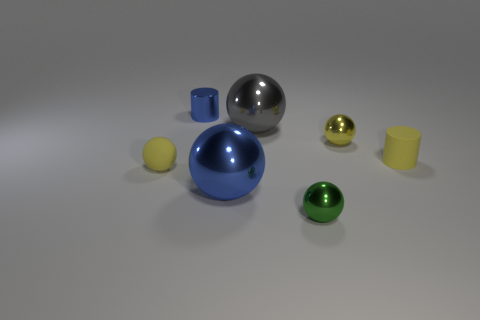Are there any small yellow matte things that have the same shape as the tiny green thing?
Make the answer very short. Yes. What is the shape of the tiny yellow metal object on the right side of the blue metallic object that is behind the tiny yellow metal ball?
Your answer should be very brief. Sphere. What number of spheres are large gray metallic objects or yellow objects?
Your answer should be very brief. 3. There is a small cylinder that is the same color as the tiny matte sphere; what material is it?
Ensure brevity in your answer.  Rubber. There is a tiny shiny object that is in front of the yellow rubber ball; is its shape the same as the rubber object right of the green sphere?
Provide a short and direct response. No. What is the color of the small metallic object that is both on the left side of the yellow shiny sphere and in front of the big gray shiny object?
Provide a short and direct response. Green. There is a tiny rubber cylinder; is it the same color as the small matte thing that is left of the gray object?
Offer a terse response. Yes. What is the size of the yellow thing that is both to the right of the small matte sphere and to the left of the rubber cylinder?
Provide a succinct answer. Small. What number of other things are the same color as the tiny shiny cylinder?
Ensure brevity in your answer.  1. There is a cylinder left of the ball that is in front of the big shiny ball that is in front of the big gray ball; what size is it?
Your answer should be compact. Small. 